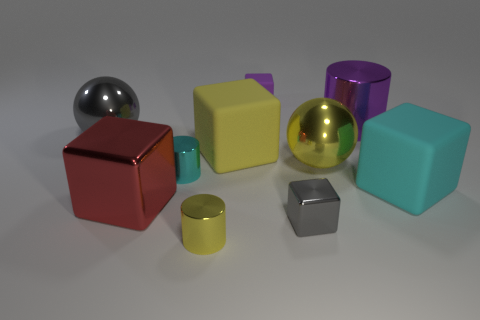How many objects are either rubber blocks behind the yellow cube or blue metallic things?
Your answer should be very brief. 1. What number of big red blocks are behind the metal cylinder that is in front of the large red shiny cube?
Offer a very short reply. 1. Is the number of matte cubes to the left of the yellow shiny cylinder less than the number of small yellow objects on the right side of the purple cylinder?
Keep it short and to the point. No. There is a large rubber thing that is behind the matte block that is in front of the small cyan cylinder; what is its shape?
Your response must be concise. Cube. How many other things are there of the same material as the big yellow ball?
Provide a succinct answer. 6. Is there anything else that is the same size as the red object?
Your answer should be very brief. Yes. Are there more tiny matte objects than purple spheres?
Provide a short and direct response. Yes. What is the size of the ball that is right of the small cube that is behind the gray thing behind the tiny gray metal thing?
Your answer should be compact. Large. Is the size of the red shiny thing the same as the yellow shiny object to the left of the yellow metallic sphere?
Ensure brevity in your answer.  No. Are there fewer cyan objects in front of the large metal cube than gray matte objects?
Your answer should be very brief. No. 